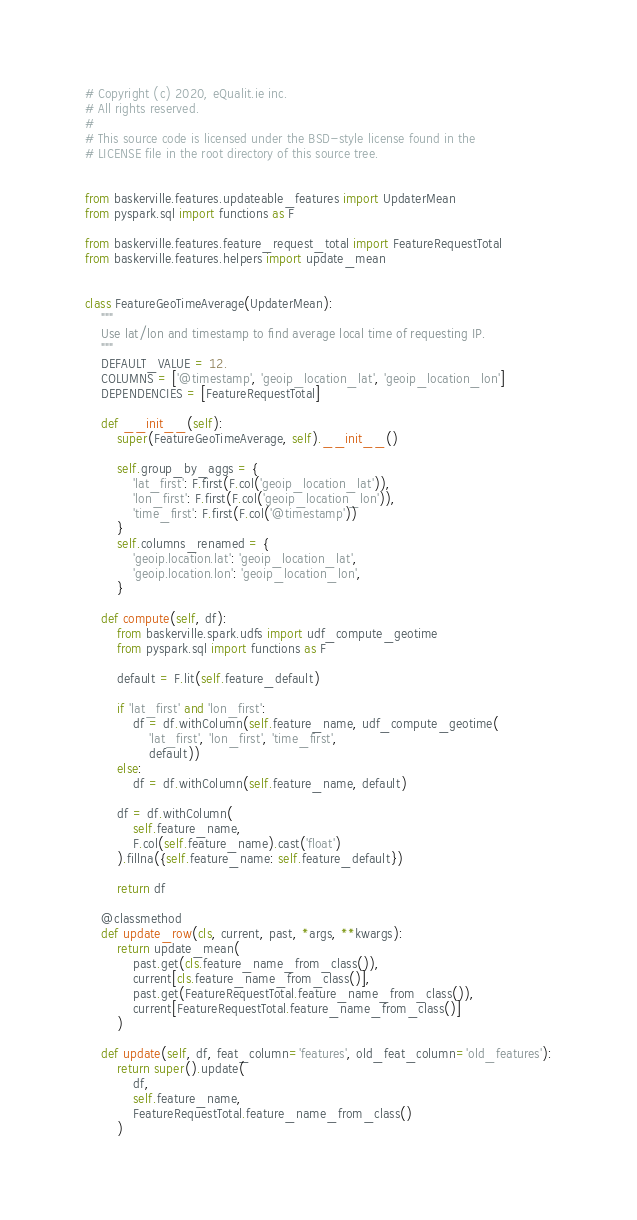Convert code to text. <code><loc_0><loc_0><loc_500><loc_500><_Python_># Copyright (c) 2020, eQualit.ie inc.
# All rights reserved.
#
# This source code is licensed under the BSD-style license found in the
# LICENSE file in the root directory of this source tree.


from baskerville.features.updateable_features import UpdaterMean
from pyspark.sql import functions as F

from baskerville.features.feature_request_total import FeatureRequestTotal
from baskerville.features.helpers import update_mean


class FeatureGeoTimeAverage(UpdaterMean):
    """
    Use lat/lon and timestamp to find average local time of requesting IP.
    """
    DEFAULT_VALUE = 12.
    COLUMNS = ['@timestamp', 'geoip_location_lat', 'geoip_location_lon']
    DEPENDENCIES = [FeatureRequestTotal]

    def __init__(self):
        super(FeatureGeoTimeAverage, self).__init__()

        self.group_by_aggs = {
            'lat_first': F.first(F.col('geoip_location_lat')),
            'lon_first': F.first(F.col('geoip_location_lon')),
            'time_first': F.first(F.col('@timestamp'))
        }
        self.columns_renamed = {
            'geoip.location.lat': 'geoip_location_lat',
            'geoip.location.lon': 'geoip_location_lon',
        }

    def compute(self, df):
        from baskerville.spark.udfs import udf_compute_geotime
        from pyspark.sql import functions as F

        default = F.lit(self.feature_default)

        if 'lat_first' and 'lon_first':
            df = df.withColumn(self.feature_name, udf_compute_geotime(
                'lat_first', 'lon_first', 'time_first',
                default))
        else:
            df = df.withColumn(self.feature_name, default)

        df = df.withColumn(
            self.feature_name,
            F.col(self.feature_name).cast('float')
        ).fillna({self.feature_name: self.feature_default})

        return df

    @classmethod
    def update_row(cls, current, past, *args, **kwargs):
        return update_mean(
            past.get(cls.feature_name_from_class()),
            current[cls.feature_name_from_class()],
            past.get(FeatureRequestTotal.feature_name_from_class()),
            current[FeatureRequestTotal.feature_name_from_class()]
        )

    def update(self, df, feat_column='features', old_feat_column='old_features'):
        return super().update(
            df,
            self.feature_name,
            FeatureRequestTotal.feature_name_from_class()
        )
</code> 